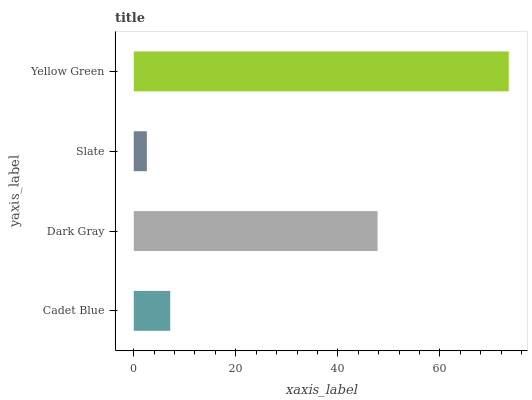Is Slate the minimum?
Answer yes or no. Yes. Is Yellow Green the maximum?
Answer yes or no. Yes. Is Dark Gray the minimum?
Answer yes or no. No. Is Dark Gray the maximum?
Answer yes or no. No. Is Dark Gray greater than Cadet Blue?
Answer yes or no. Yes. Is Cadet Blue less than Dark Gray?
Answer yes or no. Yes. Is Cadet Blue greater than Dark Gray?
Answer yes or no. No. Is Dark Gray less than Cadet Blue?
Answer yes or no. No. Is Dark Gray the high median?
Answer yes or no. Yes. Is Cadet Blue the low median?
Answer yes or no. Yes. Is Yellow Green the high median?
Answer yes or no. No. Is Yellow Green the low median?
Answer yes or no. No. 